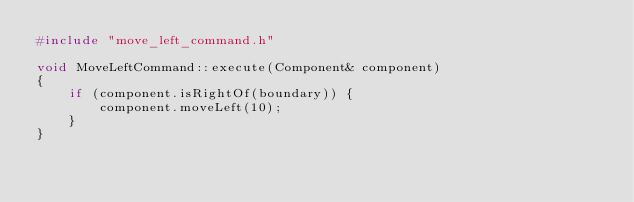Convert code to text. <code><loc_0><loc_0><loc_500><loc_500><_C++_>#include "move_left_command.h"

void MoveLeftCommand::execute(Component& component)
{
    if (component.isRightOf(boundary)) {
        component.moveLeft(10);
    }
}
</code> 